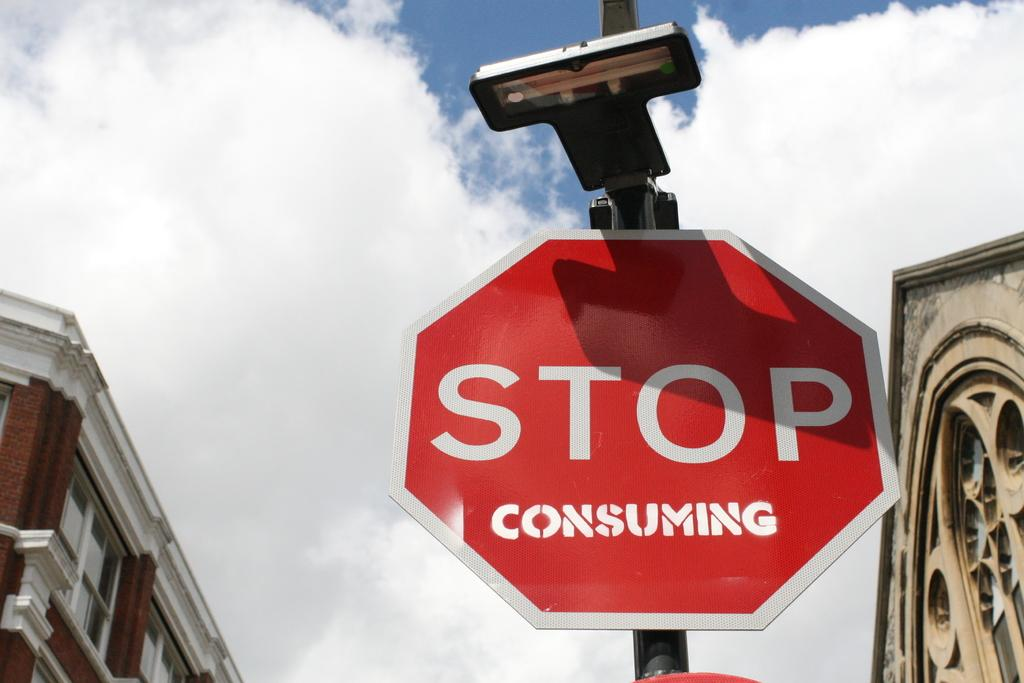Provide a one-sentence caption for the provided image. Someone has written consuming on a stop sign. 